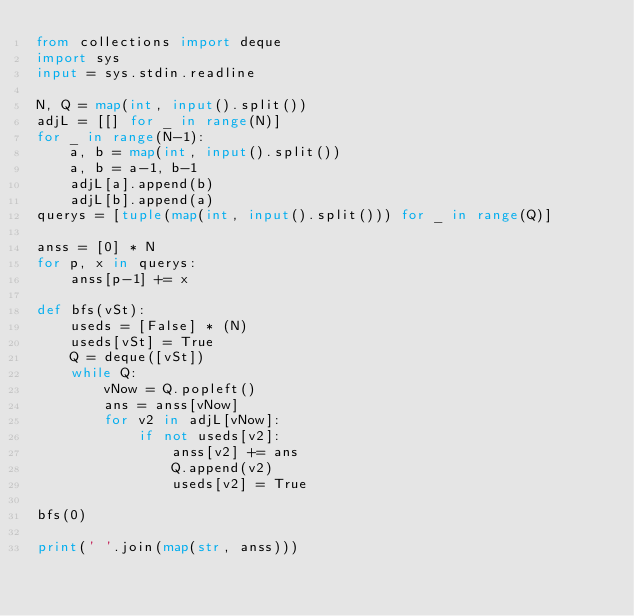Convert code to text. <code><loc_0><loc_0><loc_500><loc_500><_Python_>from collections import deque
import sys
input = sys.stdin.readline

N, Q = map(int, input().split())
adjL = [[] for _ in range(N)]
for _ in range(N-1):
    a, b = map(int, input().split())
    a, b = a-1, b-1
    adjL[a].append(b)
    adjL[b].append(a)
querys = [tuple(map(int, input().split())) for _ in range(Q)]

anss = [0] * N
for p, x in querys:
    anss[p-1] += x

def bfs(vSt):
    useds = [False] * (N)
    useds[vSt] = True
    Q = deque([vSt])
    while Q:
        vNow = Q.popleft()
        ans = anss[vNow]
        for v2 in adjL[vNow]:
            if not useds[v2]:
                anss[v2] += ans
                Q.append(v2)
                useds[v2] = True

bfs(0)

print(' '.join(map(str, anss)))
</code> 